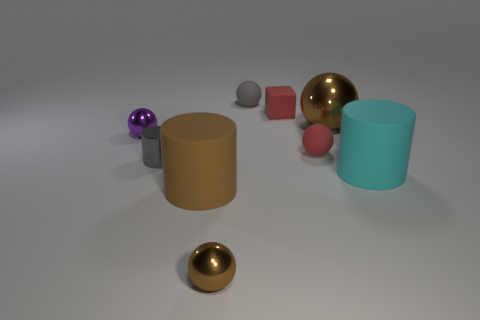What number of other objects are the same shape as the small brown metal thing?
Ensure brevity in your answer.  4. There is a metallic object that is right of the small brown metallic thing; is it the same color as the metal sphere that is in front of the tiny purple shiny sphere?
Keep it short and to the point. Yes. How big is the gray thing on the right side of the brown ball in front of the object that is to the left of the gray metallic thing?
Give a very brief answer. Small. There is a big thing that is left of the cyan thing and in front of the tiny cylinder; what shape is it?
Ensure brevity in your answer.  Cylinder. Is the number of small brown metal balls right of the small matte block the same as the number of brown balls that are behind the small brown shiny thing?
Provide a short and direct response. No. Is there a red thing that has the same material as the brown cylinder?
Keep it short and to the point. Yes. Is the big brown object that is in front of the big cyan cylinder made of the same material as the purple object?
Make the answer very short. No. There is a object that is behind the tiny purple ball and in front of the rubber cube; what size is it?
Keep it short and to the point. Large. What color is the small rubber block?
Make the answer very short. Red. How many tiny green matte objects are there?
Keep it short and to the point. 0. 